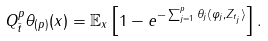Convert formula to latex. <formula><loc_0><loc_0><loc_500><loc_500>Q ^ { p } _ { \bar { t } } \theta _ { ( p ) } ( x ) = \mathbb { E } _ { x } \left [ 1 - e ^ { - \sum _ { j = 1 } ^ { p } \theta _ { j } \langle \varphi _ { j } , Z _ { t _ { j } } \rangle } \right ] .</formula> 